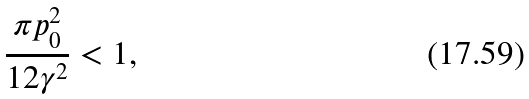Convert formula to latex. <formula><loc_0><loc_0><loc_500><loc_500>\frac { \pi p _ { 0 } ^ { 2 } } { 1 2 \gamma ^ { 2 } } < 1 ,</formula> 